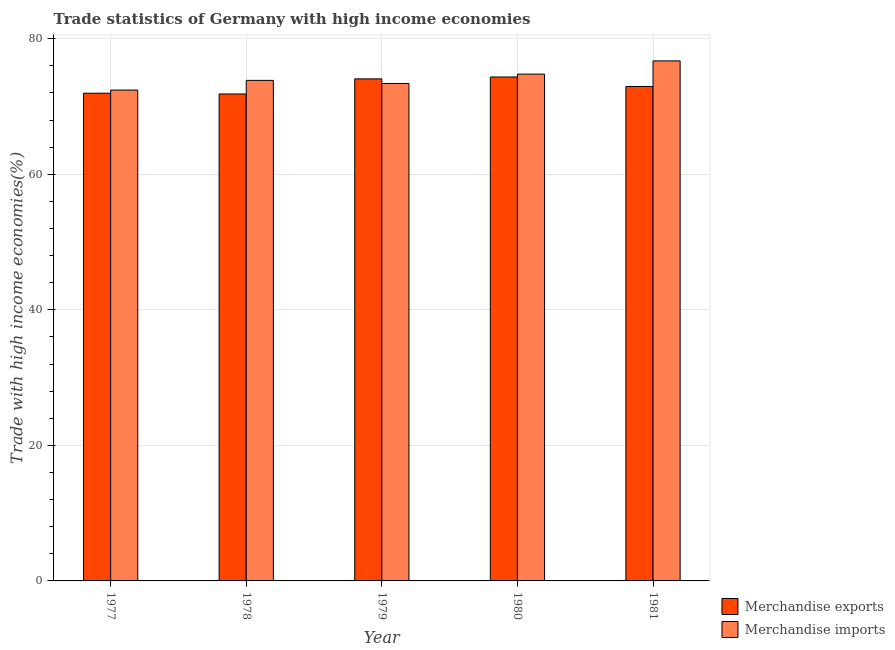Are the number of bars per tick equal to the number of legend labels?
Offer a very short reply. Yes. How many bars are there on the 5th tick from the right?
Make the answer very short. 2. What is the merchandise exports in 1977?
Provide a succinct answer. 71.97. Across all years, what is the maximum merchandise imports?
Ensure brevity in your answer.  76.74. Across all years, what is the minimum merchandise imports?
Ensure brevity in your answer.  72.43. In which year was the merchandise exports maximum?
Make the answer very short. 1980. In which year was the merchandise imports minimum?
Keep it short and to the point. 1977. What is the total merchandise imports in the graph?
Offer a very short reply. 371.21. What is the difference between the merchandise exports in 1978 and that in 1980?
Your answer should be compact. -2.51. What is the difference between the merchandise imports in 1981 and the merchandise exports in 1979?
Your response must be concise. 3.34. What is the average merchandise exports per year?
Offer a terse response. 73.04. In how many years, is the merchandise exports greater than 52 %?
Make the answer very short. 5. What is the ratio of the merchandise imports in 1977 to that in 1980?
Ensure brevity in your answer.  0.97. Is the merchandise exports in 1977 less than that in 1981?
Offer a terse response. Yes. What is the difference between the highest and the second highest merchandise exports?
Offer a terse response. 0.28. What is the difference between the highest and the lowest merchandise imports?
Keep it short and to the point. 4.31. In how many years, is the merchandise exports greater than the average merchandise exports taken over all years?
Offer a terse response. 2. What does the 1st bar from the left in 1981 represents?
Provide a succinct answer. Merchandise exports. What does the 2nd bar from the right in 1977 represents?
Provide a short and direct response. Merchandise exports. How many years are there in the graph?
Make the answer very short. 5. What is the difference between two consecutive major ticks on the Y-axis?
Your response must be concise. 20. Does the graph contain grids?
Provide a succinct answer. Yes. How many legend labels are there?
Offer a very short reply. 2. How are the legend labels stacked?
Your answer should be very brief. Vertical. What is the title of the graph?
Offer a terse response. Trade statistics of Germany with high income economies. Does "Arms exports" appear as one of the legend labels in the graph?
Your answer should be very brief. No. What is the label or title of the X-axis?
Your answer should be very brief. Year. What is the label or title of the Y-axis?
Give a very brief answer. Trade with high income economies(%). What is the Trade with high income economies(%) of Merchandise exports in 1977?
Offer a very short reply. 71.97. What is the Trade with high income economies(%) of Merchandise imports in 1977?
Keep it short and to the point. 72.43. What is the Trade with high income economies(%) in Merchandise exports in 1978?
Provide a short and direct response. 71.85. What is the Trade with high income economies(%) of Merchandise imports in 1978?
Offer a terse response. 73.86. What is the Trade with high income economies(%) of Merchandise exports in 1979?
Offer a terse response. 74.08. What is the Trade with high income economies(%) of Merchandise imports in 1979?
Provide a succinct answer. 73.4. What is the Trade with high income economies(%) of Merchandise exports in 1980?
Make the answer very short. 74.36. What is the Trade with high income economies(%) of Merchandise imports in 1980?
Keep it short and to the point. 74.78. What is the Trade with high income economies(%) of Merchandise exports in 1981?
Your response must be concise. 72.95. What is the Trade with high income economies(%) in Merchandise imports in 1981?
Provide a short and direct response. 76.74. Across all years, what is the maximum Trade with high income economies(%) of Merchandise exports?
Offer a terse response. 74.36. Across all years, what is the maximum Trade with high income economies(%) in Merchandise imports?
Your answer should be compact. 76.74. Across all years, what is the minimum Trade with high income economies(%) in Merchandise exports?
Offer a very short reply. 71.85. Across all years, what is the minimum Trade with high income economies(%) in Merchandise imports?
Provide a short and direct response. 72.43. What is the total Trade with high income economies(%) in Merchandise exports in the graph?
Your response must be concise. 365.21. What is the total Trade with high income economies(%) in Merchandise imports in the graph?
Make the answer very short. 371.21. What is the difference between the Trade with high income economies(%) in Merchandise exports in 1977 and that in 1978?
Provide a short and direct response. 0.11. What is the difference between the Trade with high income economies(%) of Merchandise imports in 1977 and that in 1978?
Provide a succinct answer. -1.43. What is the difference between the Trade with high income economies(%) in Merchandise exports in 1977 and that in 1979?
Offer a very short reply. -2.12. What is the difference between the Trade with high income economies(%) of Merchandise imports in 1977 and that in 1979?
Your answer should be compact. -0.97. What is the difference between the Trade with high income economies(%) of Merchandise exports in 1977 and that in 1980?
Your answer should be compact. -2.39. What is the difference between the Trade with high income economies(%) of Merchandise imports in 1977 and that in 1980?
Your answer should be very brief. -2.36. What is the difference between the Trade with high income economies(%) of Merchandise exports in 1977 and that in 1981?
Your response must be concise. -0.99. What is the difference between the Trade with high income economies(%) in Merchandise imports in 1977 and that in 1981?
Offer a very short reply. -4.31. What is the difference between the Trade with high income economies(%) in Merchandise exports in 1978 and that in 1979?
Offer a terse response. -2.23. What is the difference between the Trade with high income economies(%) of Merchandise imports in 1978 and that in 1979?
Ensure brevity in your answer.  0.46. What is the difference between the Trade with high income economies(%) of Merchandise exports in 1978 and that in 1980?
Give a very brief answer. -2.51. What is the difference between the Trade with high income economies(%) of Merchandise imports in 1978 and that in 1980?
Ensure brevity in your answer.  -0.93. What is the difference between the Trade with high income economies(%) in Merchandise exports in 1978 and that in 1981?
Give a very brief answer. -1.1. What is the difference between the Trade with high income economies(%) of Merchandise imports in 1978 and that in 1981?
Your answer should be compact. -2.88. What is the difference between the Trade with high income economies(%) in Merchandise exports in 1979 and that in 1980?
Offer a very short reply. -0.28. What is the difference between the Trade with high income economies(%) of Merchandise imports in 1979 and that in 1980?
Offer a terse response. -1.38. What is the difference between the Trade with high income economies(%) in Merchandise exports in 1979 and that in 1981?
Ensure brevity in your answer.  1.13. What is the difference between the Trade with high income economies(%) in Merchandise imports in 1979 and that in 1981?
Offer a very short reply. -3.34. What is the difference between the Trade with high income economies(%) of Merchandise exports in 1980 and that in 1981?
Ensure brevity in your answer.  1.41. What is the difference between the Trade with high income economies(%) of Merchandise imports in 1980 and that in 1981?
Ensure brevity in your answer.  -1.95. What is the difference between the Trade with high income economies(%) in Merchandise exports in 1977 and the Trade with high income economies(%) in Merchandise imports in 1978?
Provide a short and direct response. -1.89. What is the difference between the Trade with high income economies(%) of Merchandise exports in 1977 and the Trade with high income economies(%) of Merchandise imports in 1979?
Your response must be concise. -1.44. What is the difference between the Trade with high income economies(%) in Merchandise exports in 1977 and the Trade with high income economies(%) in Merchandise imports in 1980?
Your answer should be very brief. -2.82. What is the difference between the Trade with high income economies(%) of Merchandise exports in 1977 and the Trade with high income economies(%) of Merchandise imports in 1981?
Ensure brevity in your answer.  -4.77. What is the difference between the Trade with high income economies(%) in Merchandise exports in 1978 and the Trade with high income economies(%) in Merchandise imports in 1979?
Your answer should be very brief. -1.55. What is the difference between the Trade with high income economies(%) of Merchandise exports in 1978 and the Trade with high income economies(%) of Merchandise imports in 1980?
Give a very brief answer. -2.93. What is the difference between the Trade with high income economies(%) of Merchandise exports in 1978 and the Trade with high income economies(%) of Merchandise imports in 1981?
Ensure brevity in your answer.  -4.88. What is the difference between the Trade with high income economies(%) in Merchandise exports in 1979 and the Trade with high income economies(%) in Merchandise imports in 1980?
Offer a terse response. -0.7. What is the difference between the Trade with high income economies(%) of Merchandise exports in 1979 and the Trade with high income economies(%) of Merchandise imports in 1981?
Offer a terse response. -2.65. What is the difference between the Trade with high income economies(%) of Merchandise exports in 1980 and the Trade with high income economies(%) of Merchandise imports in 1981?
Provide a short and direct response. -2.38. What is the average Trade with high income economies(%) of Merchandise exports per year?
Your answer should be very brief. 73.04. What is the average Trade with high income economies(%) in Merchandise imports per year?
Your answer should be compact. 74.24. In the year 1977, what is the difference between the Trade with high income economies(%) of Merchandise exports and Trade with high income economies(%) of Merchandise imports?
Your answer should be compact. -0.46. In the year 1978, what is the difference between the Trade with high income economies(%) in Merchandise exports and Trade with high income economies(%) in Merchandise imports?
Give a very brief answer. -2.01. In the year 1979, what is the difference between the Trade with high income economies(%) in Merchandise exports and Trade with high income economies(%) in Merchandise imports?
Make the answer very short. 0.68. In the year 1980, what is the difference between the Trade with high income economies(%) of Merchandise exports and Trade with high income economies(%) of Merchandise imports?
Your response must be concise. -0.42. In the year 1981, what is the difference between the Trade with high income economies(%) of Merchandise exports and Trade with high income economies(%) of Merchandise imports?
Provide a succinct answer. -3.78. What is the ratio of the Trade with high income economies(%) of Merchandise exports in 1977 to that in 1978?
Provide a short and direct response. 1. What is the ratio of the Trade with high income economies(%) in Merchandise imports in 1977 to that in 1978?
Provide a short and direct response. 0.98. What is the ratio of the Trade with high income economies(%) of Merchandise exports in 1977 to that in 1979?
Your answer should be compact. 0.97. What is the ratio of the Trade with high income economies(%) in Merchandise imports in 1977 to that in 1979?
Give a very brief answer. 0.99. What is the ratio of the Trade with high income economies(%) of Merchandise exports in 1977 to that in 1980?
Your answer should be very brief. 0.97. What is the ratio of the Trade with high income economies(%) of Merchandise imports in 1977 to that in 1980?
Give a very brief answer. 0.97. What is the ratio of the Trade with high income economies(%) in Merchandise exports in 1977 to that in 1981?
Make the answer very short. 0.99. What is the ratio of the Trade with high income economies(%) of Merchandise imports in 1977 to that in 1981?
Provide a short and direct response. 0.94. What is the ratio of the Trade with high income economies(%) in Merchandise exports in 1978 to that in 1979?
Your answer should be compact. 0.97. What is the ratio of the Trade with high income economies(%) in Merchandise exports in 1978 to that in 1980?
Ensure brevity in your answer.  0.97. What is the ratio of the Trade with high income economies(%) of Merchandise imports in 1978 to that in 1980?
Your answer should be compact. 0.99. What is the ratio of the Trade with high income economies(%) in Merchandise exports in 1978 to that in 1981?
Offer a terse response. 0.98. What is the ratio of the Trade with high income economies(%) in Merchandise imports in 1978 to that in 1981?
Give a very brief answer. 0.96. What is the ratio of the Trade with high income economies(%) of Merchandise exports in 1979 to that in 1980?
Provide a short and direct response. 1. What is the ratio of the Trade with high income economies(%) in Merchandise imports in 1979 to that in 1980?
Offer a very short reply. 0.98. What is the ratio of the Trade with high income economies(%) in Merchandise exports in 1979 to that in 1981?
Offer a terse response. 1.02. What is the ratio of the Trade with high income economies(%) of Merchandise imports in 1979 to that in 1981?
Your answer should be compact. 0.96. What is the ratio of the Trade with high income economies(%) of Merchandise exports in 1980 to that in 1981?
Give a very brief answer. 1.02. What is the ratio of the Trade with high income economies(%) of Merchandise imports in 1980 to that in 1981?
Keep it short and to the point. 0.97. What is the difference between the highest and the second highest Trade with high income economies(%) of Merchandise exports?
Make the answer very short. 0.28. What is the difference between the highest and the second highest Trade with high income economies(%) in Merchandise imports?
Give a very brief answer. 1.95. What is the difference between the highest and the lowest Trade with high income economies(%) in Merchandise exports?
Provide a short and direct response. 2.51. What is the difference between the highest and the lowest Trade with high income economies(%) in Merchandise imports?
Your response must be concise. 4.31. 